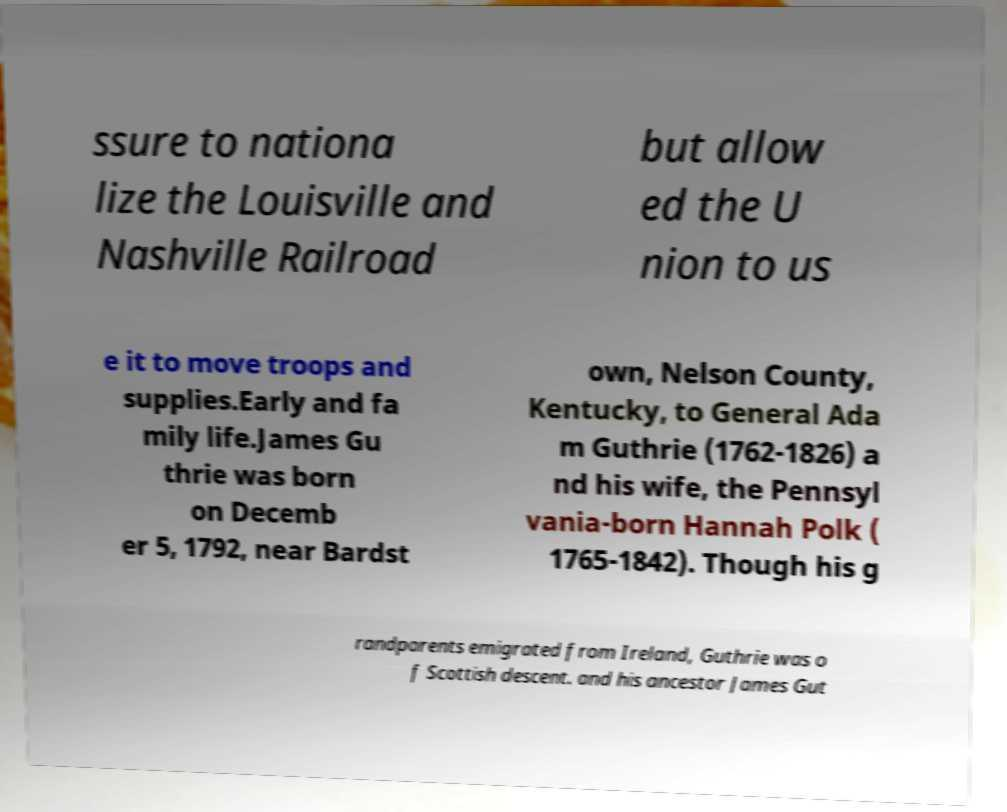Can you accurately transcribe the text from the provided image for me? ssure to nationa lize the Louisville and Nashville Railroad but allow ed the U nion to us e it to move troops and supplies.Early and fa mily life.James Gu thrie was born on Decemb er 5, 1792, near Bardst own, Nelson County, Kentucky, to General Ada m Guthrie (1762-1826) a nd his wife, the Pennsyl vania-born Hannah Polk ( 1765-1842). Though his g randparents emigrated from Ireland, Guthrie was o f Scottish descent. and his ancestor James Gut 